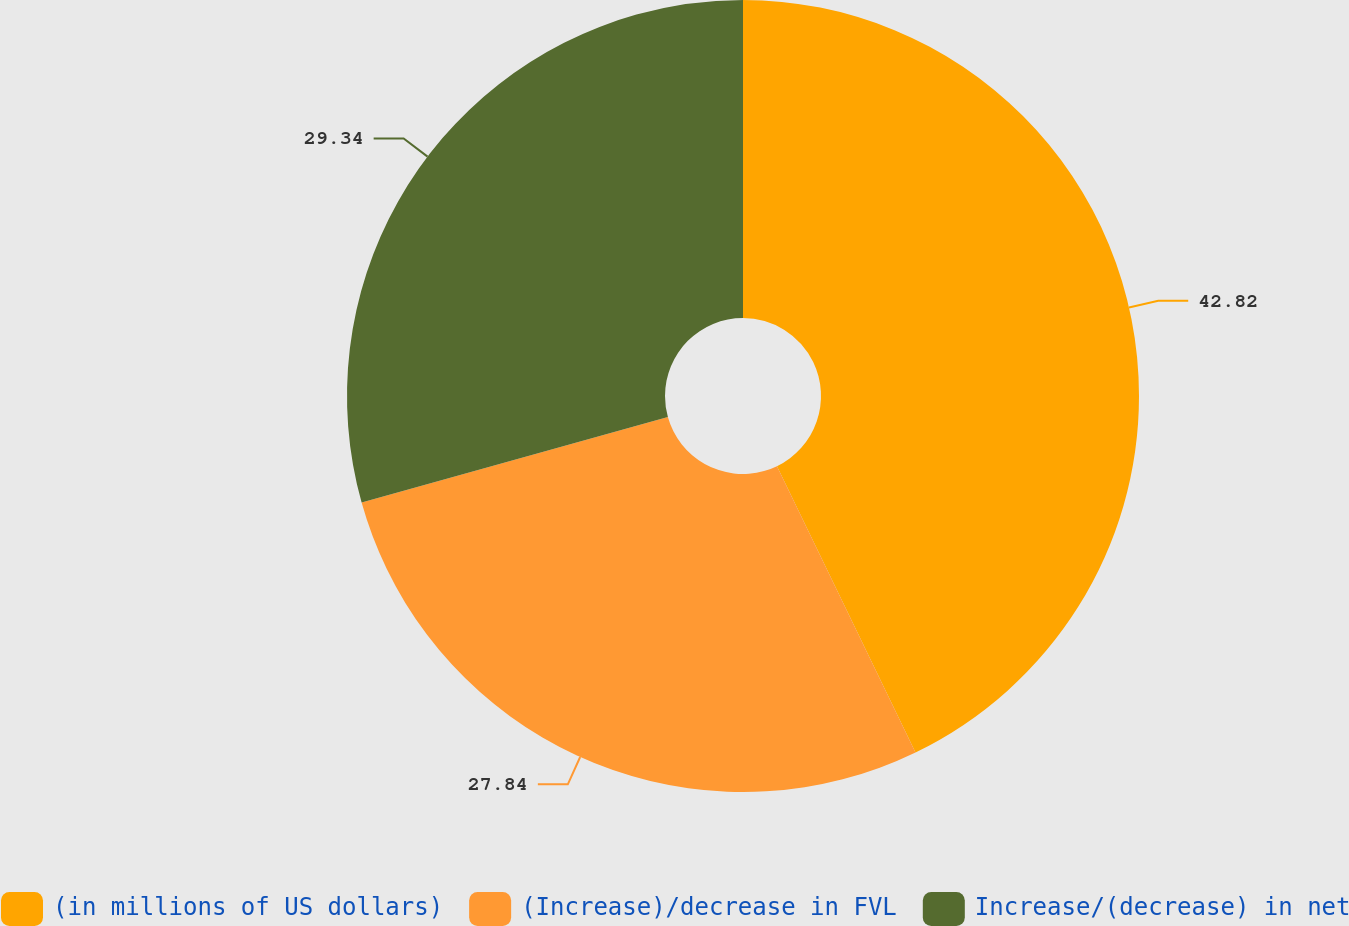Convert chart. <chart><loc_0><loc_0><loc_500><loc_500><pie_chart><fcel>(in millions of US dollars)<fcel>(Increase)/decrease in FVL<fcel>Increase/(decrease) in net<nl><fcel>42.83%<fcel>27.84%<fcel>29.34%<nl></chart> 